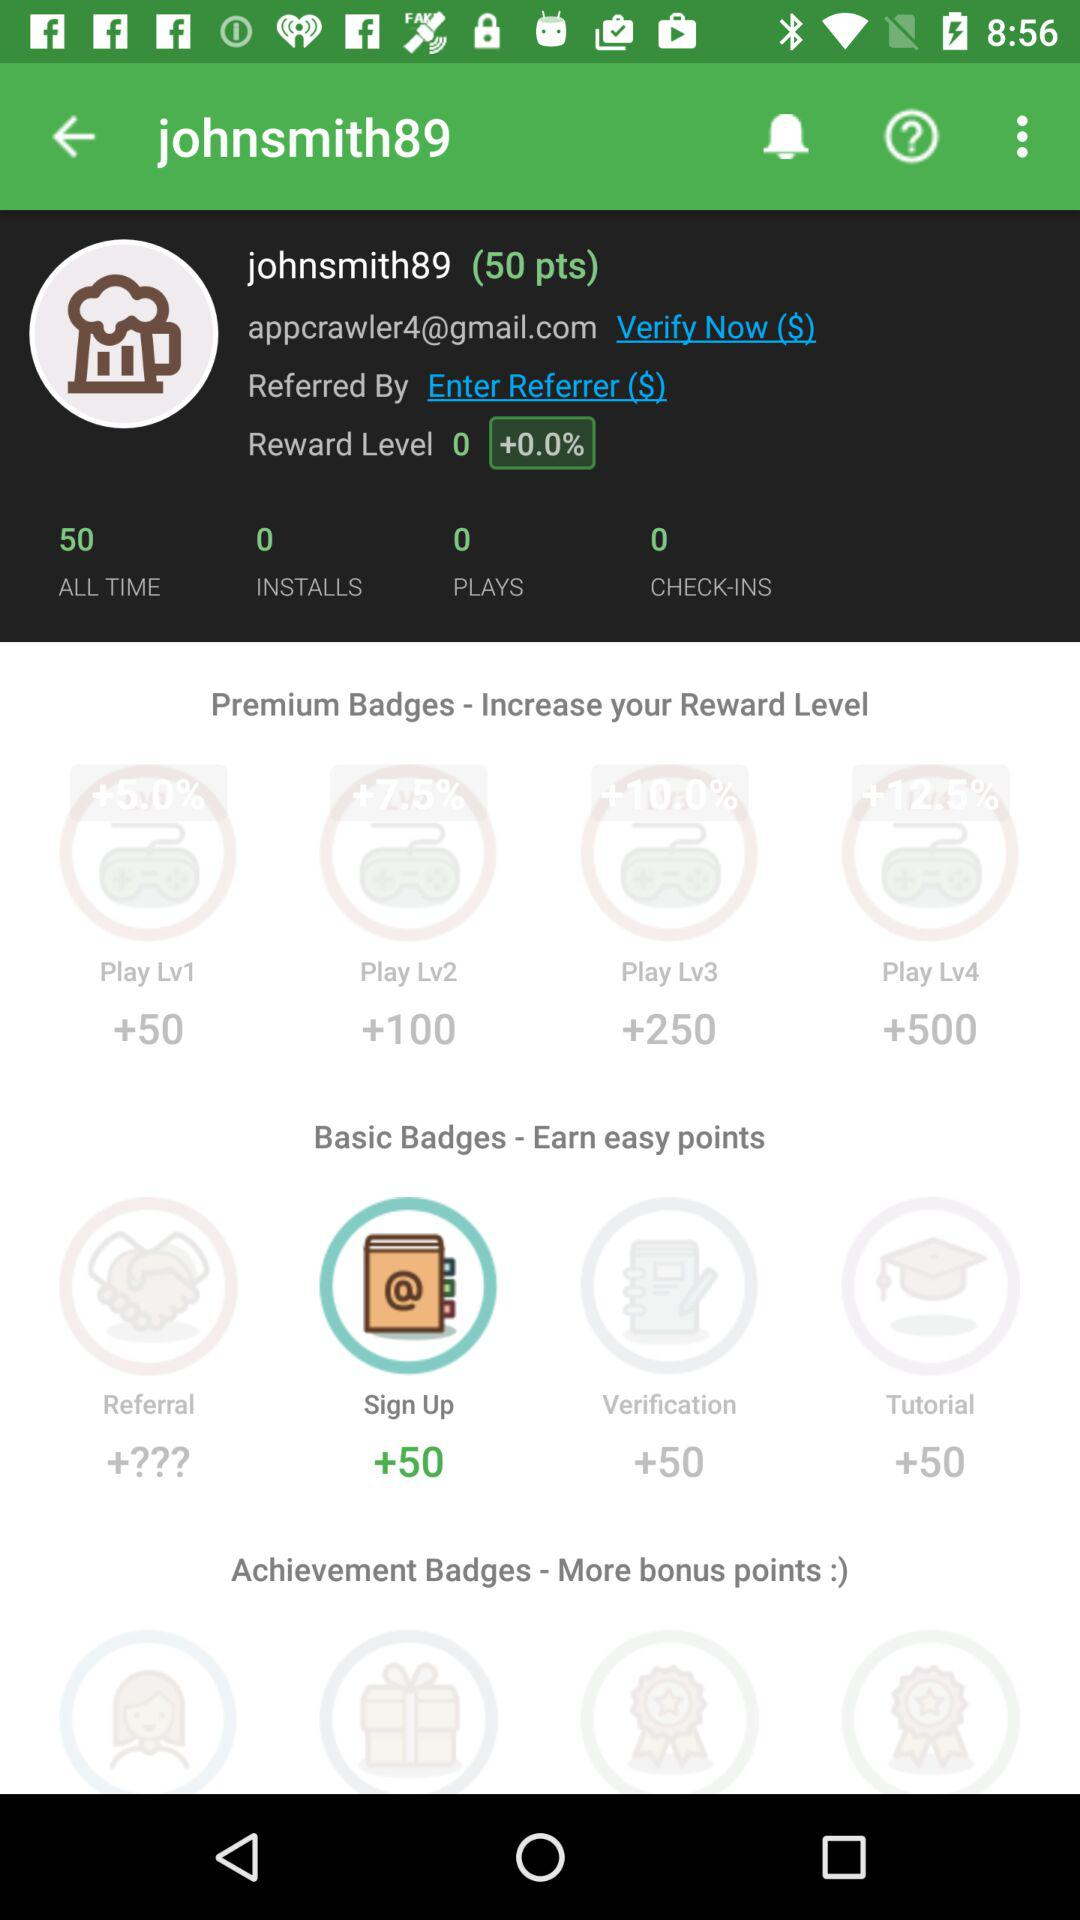How many check-ins are there? There are zero check-ins. 